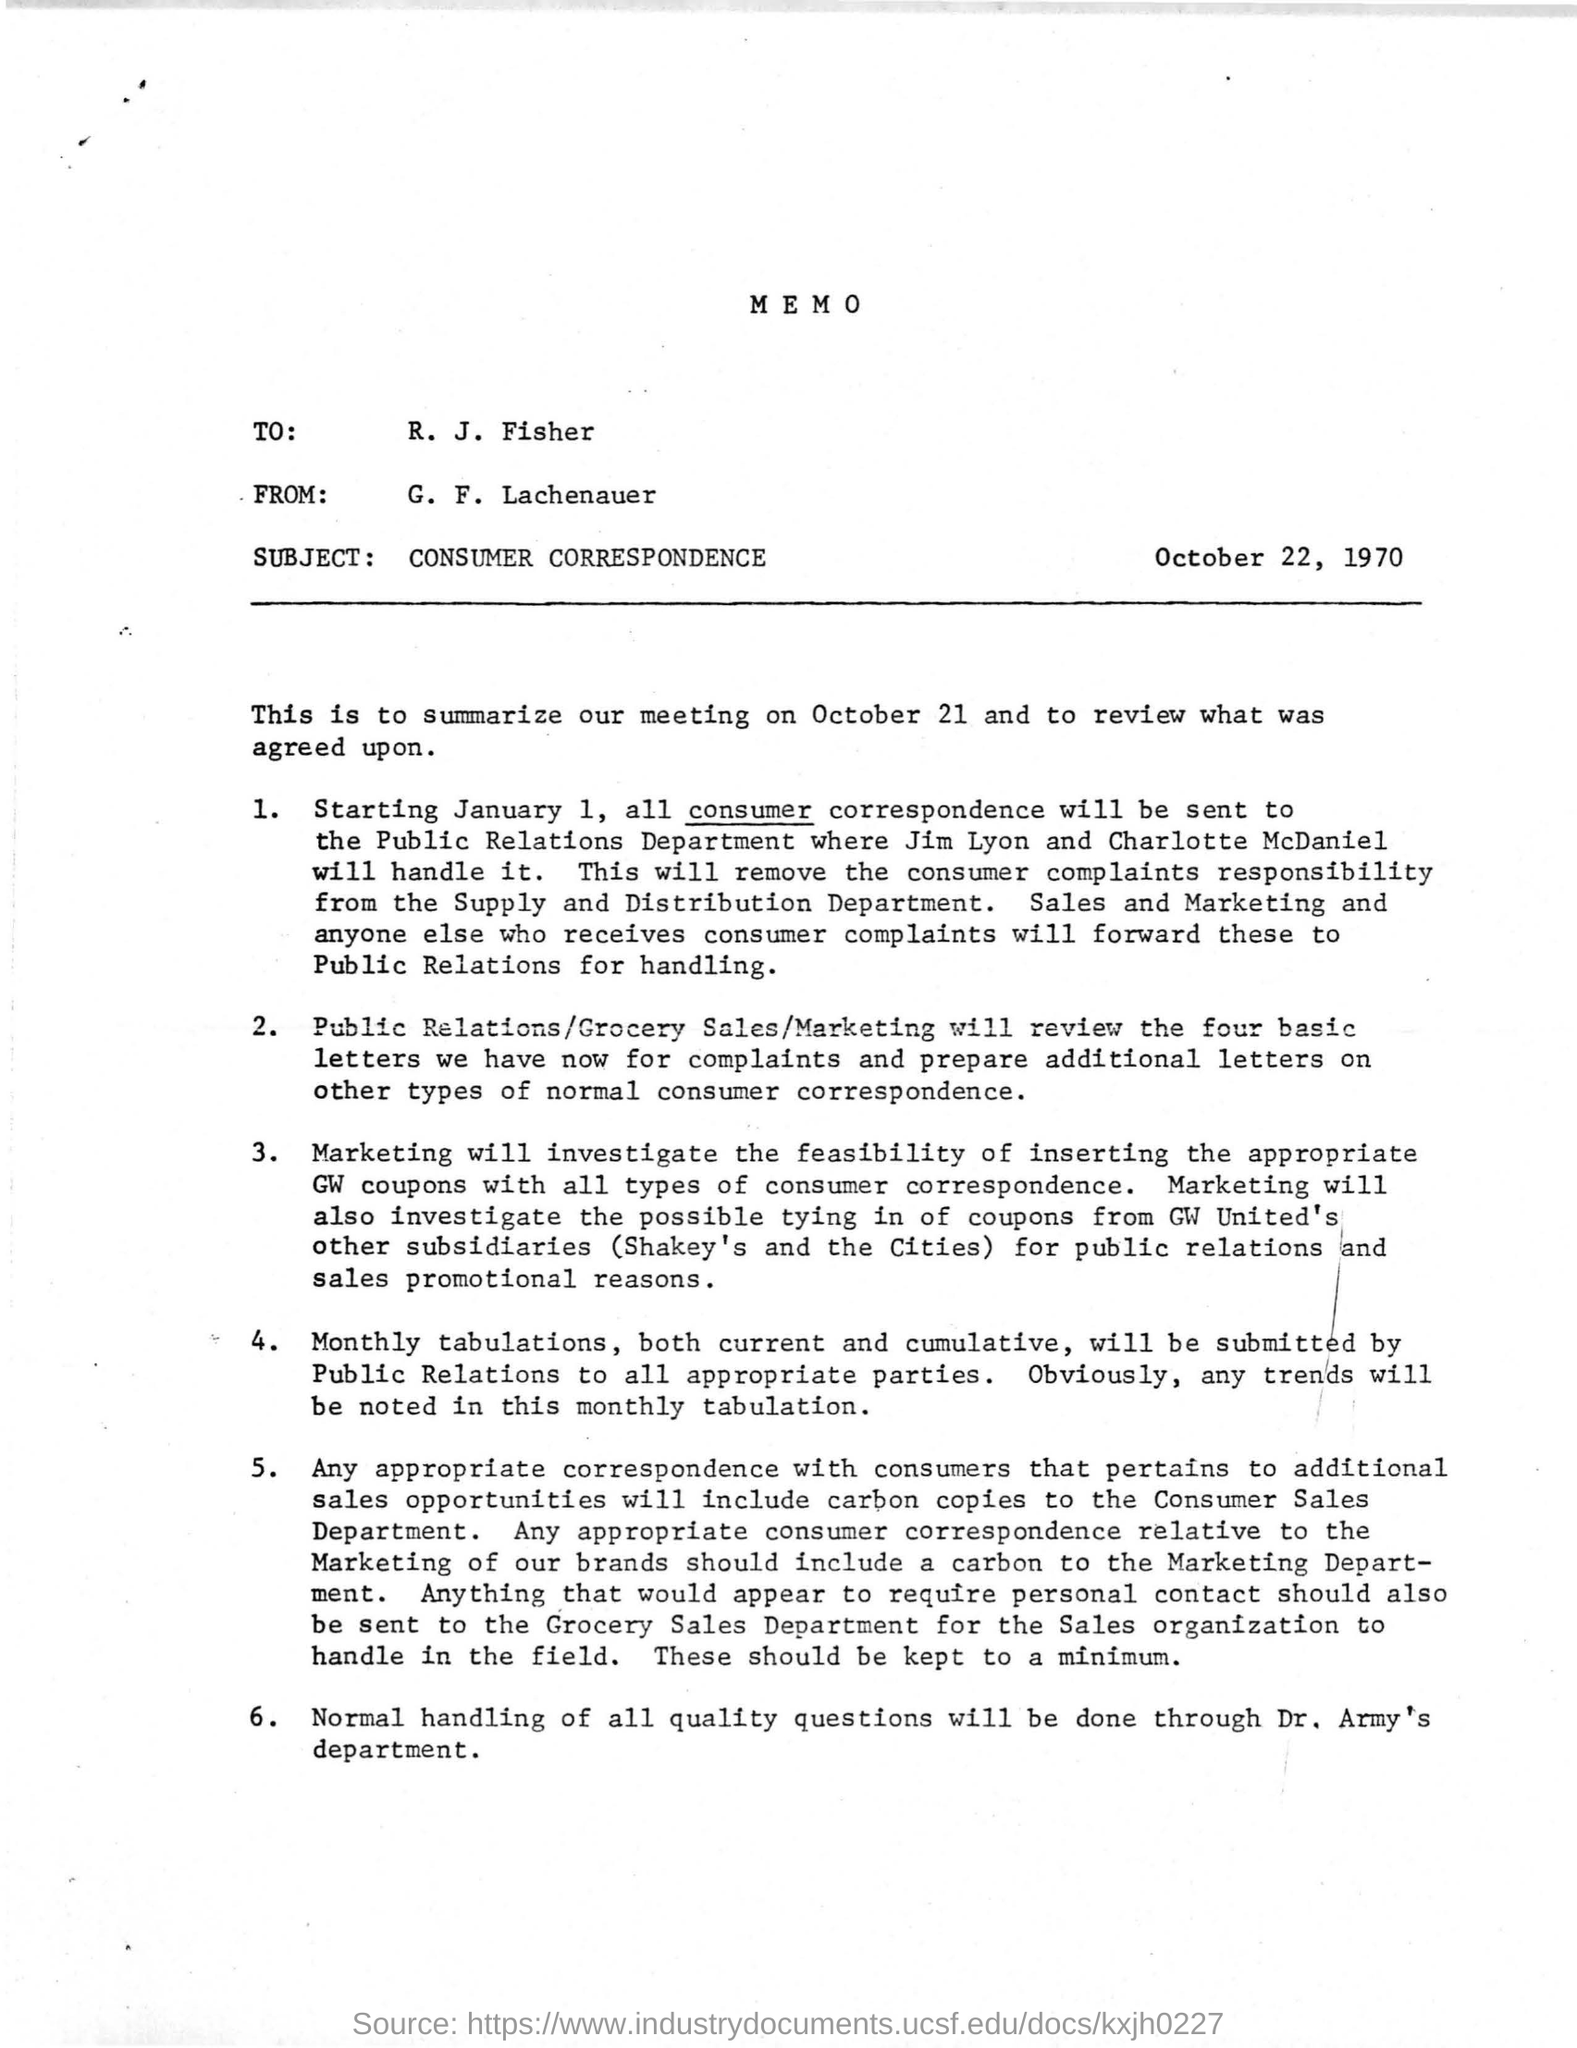List a handful of essential elements in this visual. The memo is dated on October 22, 1970. The subject of the memo is "consumer correspondence. 